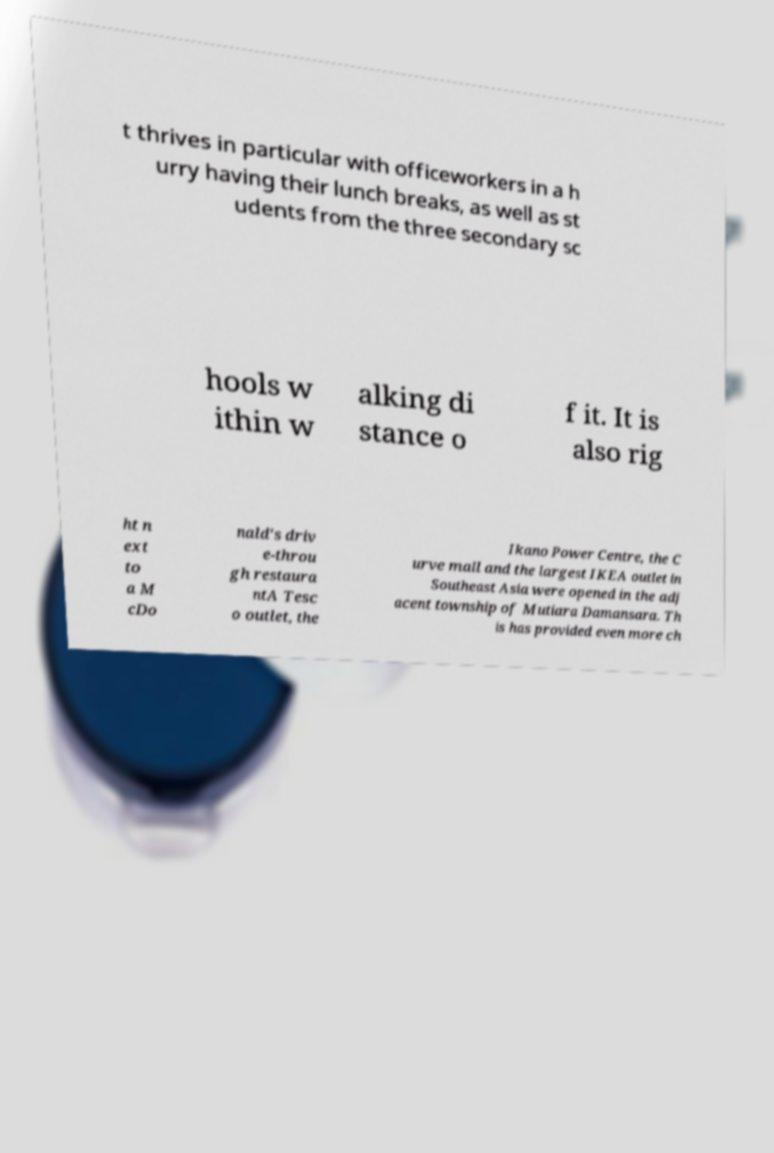Could you extract and type out the text from this image? t thrives in particular with officeworkers in a h urry having their lunch breaks, as well as st udents from the three secondary sc hools w ithin w alking di stance o f it. It is also rig ht n ext to a M cDo nald's driv e-throu gh restaura ntA Tesc o outlet, the Ikano Power Centre, the C urve mall and the largest IKEA outlet in Southeast Asia were opened in the adj acent township of Mutiara Damansara. Th is has provided even more ch 